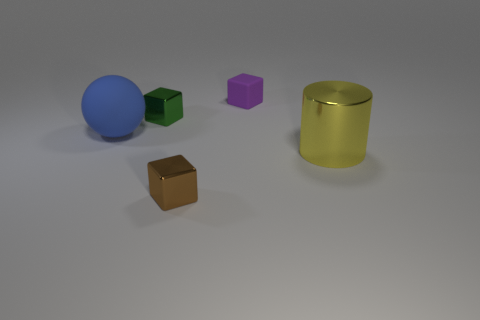Is the number of things greater than the number of big blue spheres?
Keep it short and to the point. Yes. How big is the metallic object that is both in front of the big blue matte object and on the left side of the big yellow cylinder?
Give a very brief answer. Small. Do the block that is in front of the large ball and the big object behind the big yellow metal object have the same material?
Your answer should be very brief. No. What shape is the rubber object that is the same size as the brown metal cube?
Offer a terse response. Cube. Are there fewer large metallic things than large things?
Make the answer very short. Yes. There is a matte object that is in front of the tiny purple rubber block; is there a blue matte ball that is behind it?
Make the answer very short. No. There is a metal cube on the left side of the metal cube that is in front of the green block; are there any rubber things to the right of it?
Your answer should be compact. Yes. There is a tiny shiny object that is behind the big rubber object; is it the same shape as the purple rubber thing that is left of the yellow object?
Offer a very short reply. Yes. The thing that is the same material as the sphere is what color?
Ensure brevity in your answer.  Purple. Are there fewer small purple matte cubes on the right side of the yellow metal thing than large blue rubber objects?
Your answer should be very brief. Yes. 